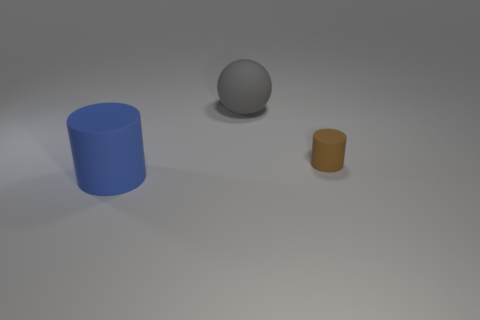How many big blue cylinders are made of the same material as the large gray sphere?
Your answer should be compact. 1. There is a large matte thing that is in front of the gray matte ball; is it the same color as the small object?
Provide a short and direct response. No. How many blue things are large rubber cylinders or large rubber objects?
Provide a short and direct response. 1. Are there any other things that have the same material as the small cylinder?
Keep it short and to the point. Yes. Does the large blue cylinder that is in front of the rubber sphere have the same material as the tiny cylinder?
Make the answer very short. Yes. How many objects are small green spheres or big objects that are in front of the sphere?
Your response must be concise. 1. What number of large objects are on the left side of the large object behind the cylinder left of the gray object?
Provide a succinct answer. 1. There is a big rubber thing behind the brown cylinder; is it the same shape as the small brown object?
Keep it short and to the point. No. There is a matte thing that is in front of the small rubber cylinder; are there any brown things in front of it?
Ensure brevity in your answer.  No. How many brown cylinders are there?
Ensure brevity in your answer.  1. 